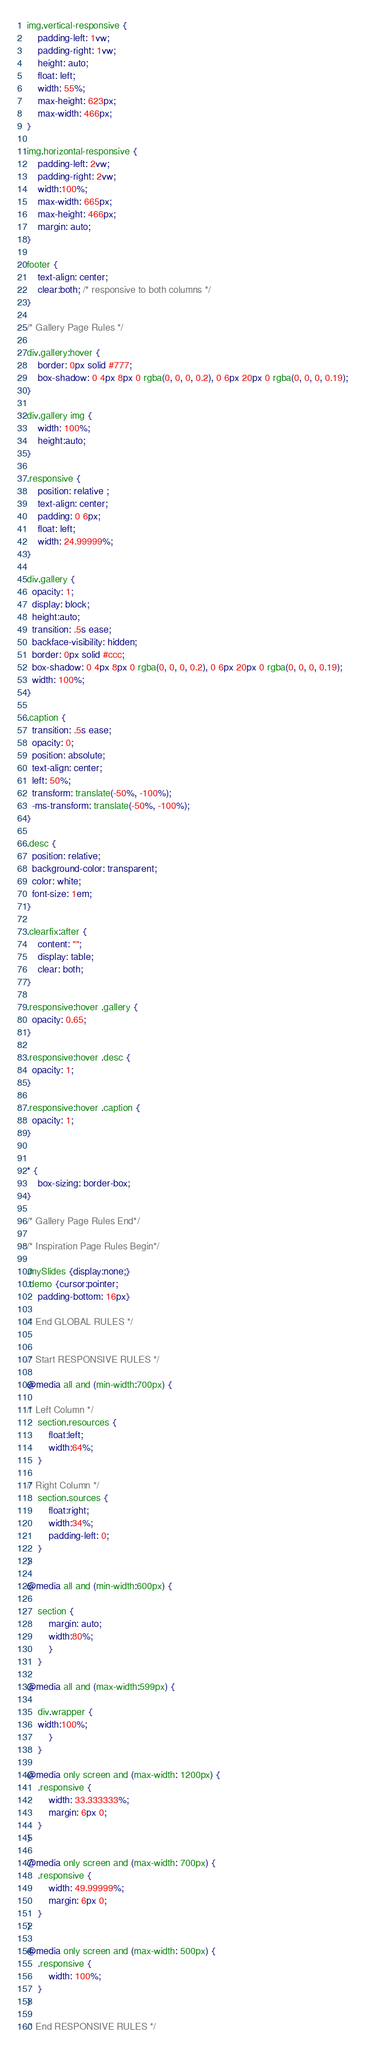<code> <loc_0><loc_0><loc_500><loc_500><_CSS_>img.vertical-responsive {
    padding-left: 1vw;
    padding-right: 1vw;
    height: auto;
    float: left; 
    width: 55%;
    max-height: 623px; 
    max-width: 466px;
}

img.horizontal-responsive {
    padding-left: 2vw;
    padding-right: 2vw;
    width:100%;
    max-width: 665px;
    max-height: 466px;
    margin: auto;
}

footer {
    text-align: center;
    clear:both; /* responsive to both columns */
}

/* Gallery Page Rules */

div.gallery:hover {
    border: 0px solid #777;
    box-shadow: 0 4px 8px 0 rgba(0, 0, 0, 0.2), 0 6px 20px 0 rgba(0, 0, 0, 0.19);
} 

div.gallery img {
    width: 100%;
    height:auto; 
}

.responsive {
    position: relative ;
    text-align: center;
    padding: 0 6px;
    float: left;
    width: 24.99999%;
}

div.gallery {
  opacity: 1;
  display: block;
  height:auto;
  transition: .5s ease;
  backface-visibility: hidden;
  border: 0px solid #ccc;
  box-shadow: 0 4px 8px 0 rgba(0, 0, 0, 0.2), 0 6px 20px 0 rgba(0, 0, 0, 0.19);
  width: 100%;
}

.caption {
  transition: .5s ease;
  opacity: 0;
  position: absolute;
  text-align: center;
  left: 50%;
  transform: translate(-50%, -100%);
  -ms-transform: translate(-50%, -100%);
}

.desc {
  position: relative;
  background-color: transparent;
  color: white;
  font-size: 1em;
}

.clearfix:after {
    content: "";
    display: table;
    clear: both;
} 

.responsive:hover .gallery {
  opacity: 0.65;
}

.responsive:hover .desc {
  opacity: 1;
}

.responsive:hover .caption {
  opacity: 1;
}


* {
    box-sizing: border-box;
} 

/* Gallery Page Rules End*/

/* Inspiration Page Rules Begin*/

.mySlides {display:none;}
.demo {cursor:pointer;
    padding-bottom: 16px}

/* End GLOBAL RULES */


/* Start RESPONSIVE RULES */

@media all and (min-width:700px) {

/* Left Column */ 
    section.resources {
        float:left;
        width:64%;
    }
     
/* Right Column */ 
    section.sources {
        float:right;
        width:34%;
        padding-left: 0;
    }    
}

@media all and (min-width:600px) {

    section {
        margin: auto;
        width:80%;
        }
    }

@media all and (max-width:599px) {

    div.wrapper {  
    width:100%;
        }   
    }

@media only screen and (max-width: 1200px) {
    .responsive {
        width: 33.333333%;
        margin: 6px 0;
    }
}

@media only screen and (max-width: 700px) {
    .responsive {
        width: 49.99999%;
        margin: 6px 0;
    }
}

@media only screen and (max-width: 500px) {
    .responsive {
        width: 100%;
    }
}

/* End RESPONSIVE RULES */</code> 